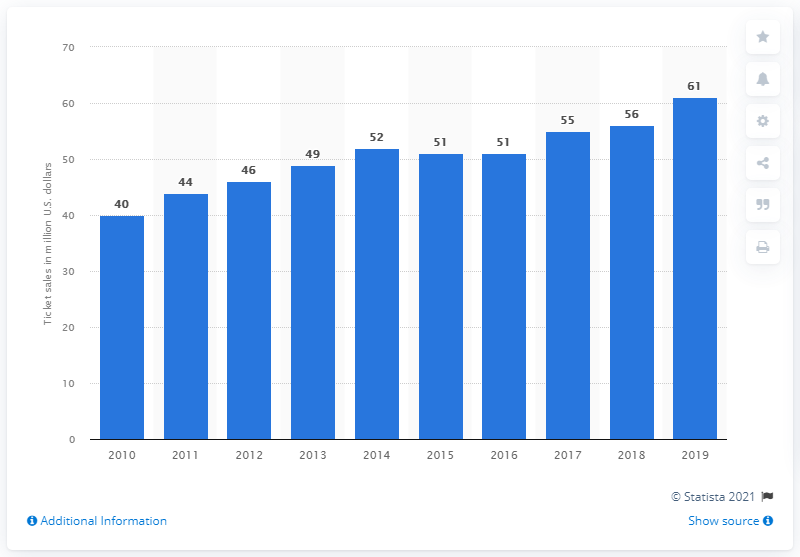Give some essential details in this illustration. In 2019, the Detroit Lions generated $61 million in gate receipts, which represents a significant portion of their overall revenue. 